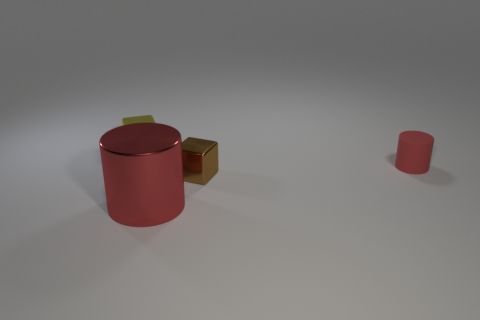Add 1 large yellow metallic objects. How many objects exist? 5 Add 1 small metallic objects. How many small metallic objects exist? 3 Subtract 0 green balls. How many objects are left? 4 Subtract all big red things. Subtract all big red metallic things. How many objects are left? 2 Add 3 tiny yellow things. How many tiny yellow things are left? 4 